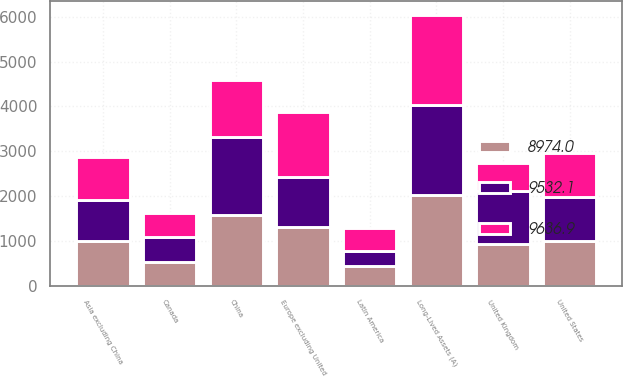Convert chart to OTSL. <chart><loc_0><loc_0><loc_500><loc_500><stacked_bar_chart><ecel><fcel>Long-Lived Assets (A)<fcel>United States<fcel>Canada<fcel>Europe excluding United<fcel>United Kingdom<fcel>Asia excluding China<fcel>China<fcel>Latin America<nl><fcel>9532.1<fcel>2015<fcel>989.9<fcel>577.4<fcel>1102.3<fcel>1196.3<fcel>914.2<fcel>1732.7<fcel>337.3<nl><fcel>8974<fcel>2014<fcel>989.9<fcel>518<fcel>1319.3<fcel>926.1<fcel>989.9<fcel>1582.7<fcel>440.1<nl><fcel>9636.9<fcel>2013<fcel>989.9<fcel>522.3<fcel>1456.2<fcel>612.6<fcel>962.3<fcel>1281.7<fcel>506.8<nl></chart> 